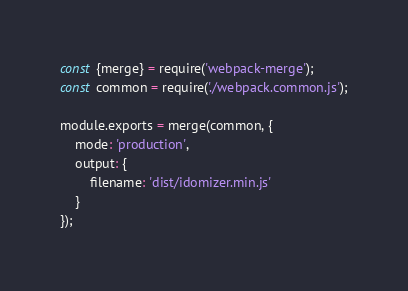Convert code to text. <code><loc_0><loc_0><loc_500><loc_500><_JavaScript_>const {merge} = require('webpack-merge');
const common = require('./webpack.common.js');

module.exports = merge(common, {
    mode: 'production',
    output: {
        filename: 'dist/idomizer.min.js'
    }
});
</code> 